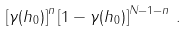Convert formula to latex. <formula><loc_0><loc_0><loc_500><loc_500>\left [ \gamma ( h _ { 0 } ) \right ] ^ { n } \left [ 1 - \gamma ( h _ { 0 } ) \right ] ^ { N - 1 - n } \, .</formula> 